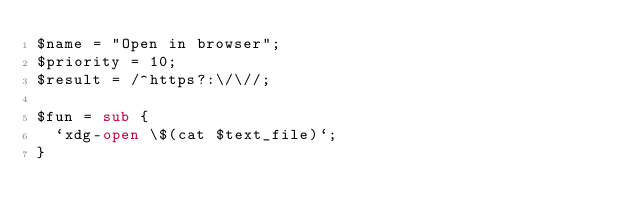<code> <loc_0><loc_0><loc_500><loc_500><_Perl_>$name = "Open in browser";
$priority = 10;
$result = /^https?:\/\//;

$fun = sub {
	`xdg-open \$(cat $text_file)`;
}
</code> 